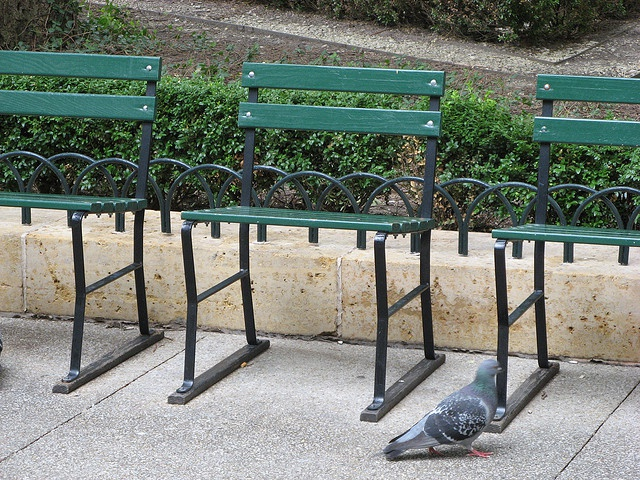Describe the objects in this image and their specific colors. I can see bench in black, teal, gray, and darkgray tones, bench in black, teal, and darkgray tones, chair in black, teal, gray, and darkgray tones, bench in black, teal, gray, and lightgray tones, and bird in black, gray, and darkgray tones in this image. 